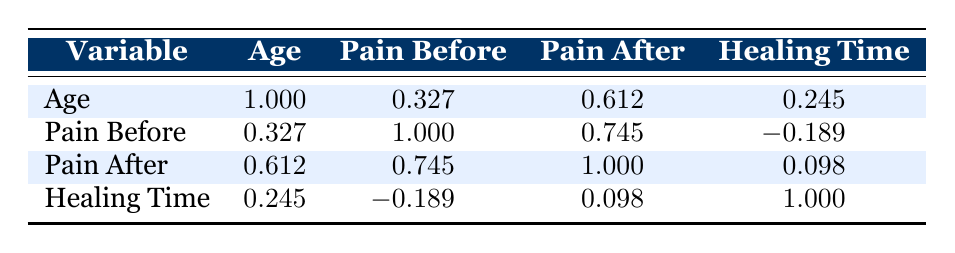What's the correlation between age and pain level before treatment? Looking at the correlation table, the correlation coefficient between age and pain level before treatment is 0.327. This indicates a positive correlation, suggesting that as age increases, the pain level before treatment tends to increase.
Answer: 0.327 What's the healing time for the patient with the highest pain level before the treatment? First, we identify the patient with the highest pain level before treatment. Patient 5 has the highest pain level of 10. According to the table, this patient's healing time is 8 days.
Answer: 8 Is there a relationship between pain level before treatment and pain level after treatment? The correlation coefficient between pain level before treatment and pain level after treatment is 0.745. This indicates a strong positive correlation, meaning that higher pain levels before treatment are associated with higher pain levels after treatment.
Answer: Yes What is the average healing time for all patients in the data set? To calculate the average healing time, we add all the healing times together: 7 + 10 + 5 + 14 + 8 = 44 days. There are 5 patients, so the average healing time is 44/5 = 8.8 days.
Answer: 8.8 Does the treatment success relate to the age of the patients? To evaluate this, we look at the treatment success outcomes. Patients 1, 2, 3, and 5 were successful (ages 34, 50, 28, and 65), while patient 4 (age 45) was not. Correlation itself is not calculated directly with success as a binary variable here, but we can observe ages of successful versus unsuccessful treatments. It indicates that the outcome isn't strongly dependent on age alone.
Answer: No What is the correlation between pain after treatment and healing time? The correlation coefficient between pain level after treatment and healing time is 0.098, which indicates a very weak positive correlation. This suggests that changes in pain level after treatment have little to no consistent relationship with healing time.
Answer: 0.098 Which patient had the lowest pain level after treatment, and what was their healing time? Patient 3 had the lowest pain level after treatment at 1. Their healing time was recorded as 5 days.
Answer: 5 What is the correlation coefficient between pain before treatment and healing time? According to the table, the correlation coefficient between pain level before treatment and healing time is -0.189, indicating a slight negative correlation. This means that as pain before treatment increases, healing time may slightly decrease, but the correlation is weak.
Answer: -0.189 